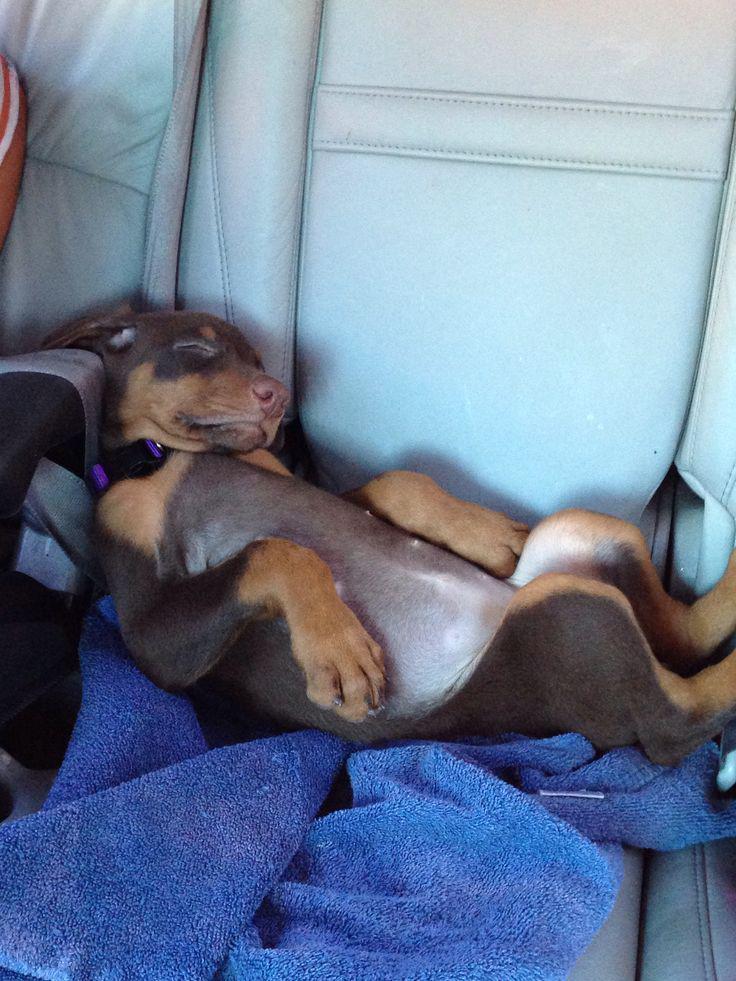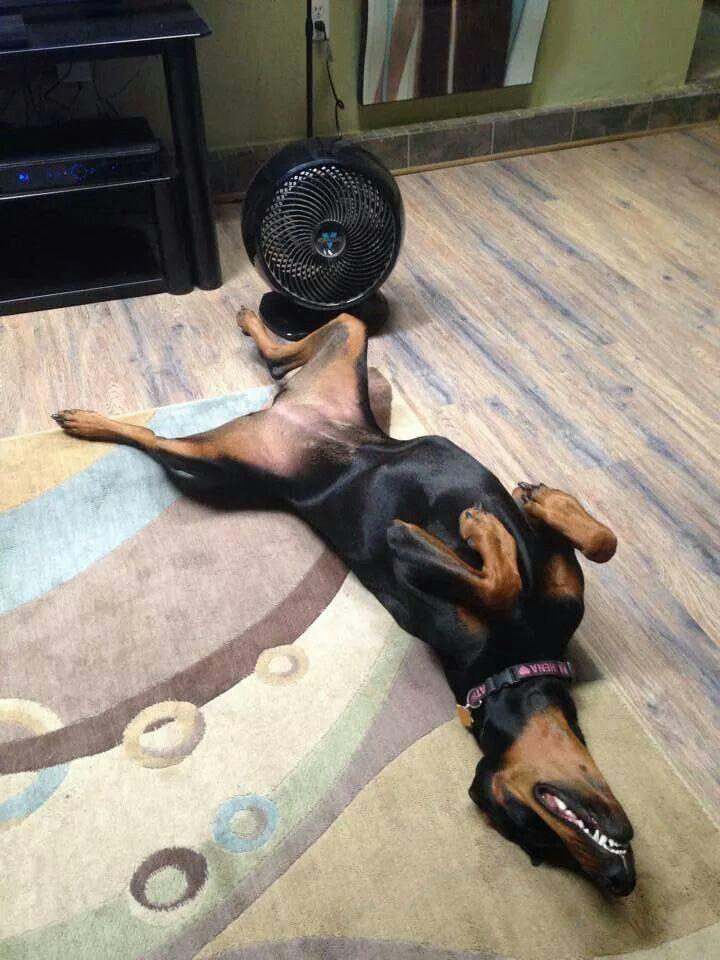The first image is the image on the left, the second image is the image on the right. Assess this claim about the two images: "All dogs shown are sleeping on their backs with their front paws bent, and the dog on the right has its head flung back and its muzzle at the lower right.". Correct or not? Answer yes or no. Yes. The first image is the image on the left, the second image is the image on the right. Evaluate the accuracy of this statement regarding the images: "Both images show a dog sleeping on their back exposing their belly.". Is it true? Answer yes or no. Yes. 